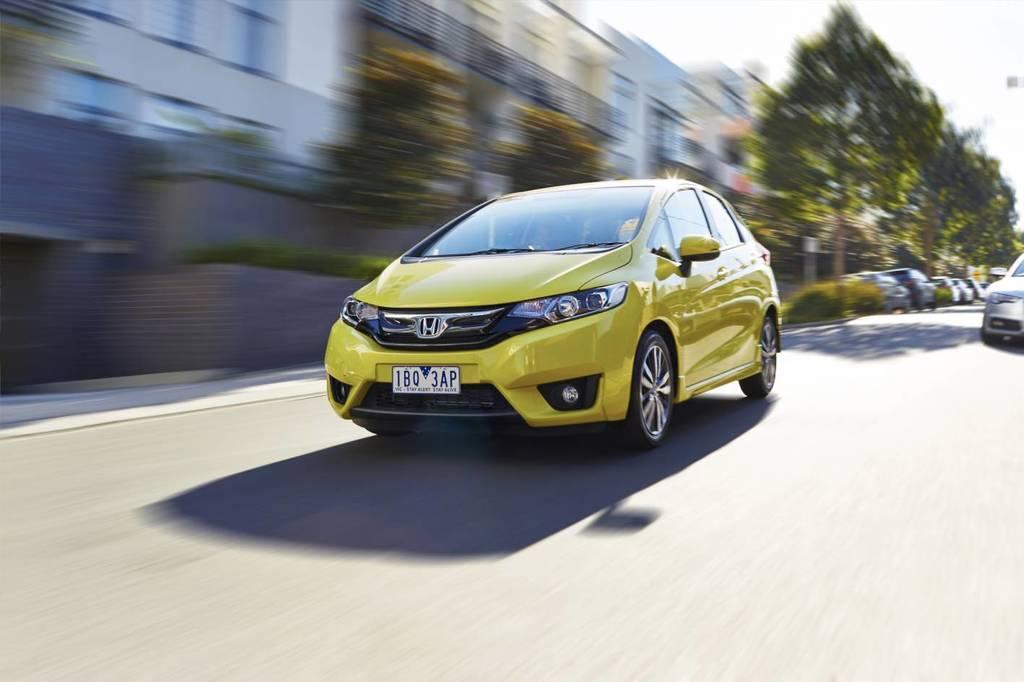Please provide a concise description of this image. In this image I can see there is a car moving on the road. There are few trees in the background, there are a few buildings and the background of the image is blurred. 